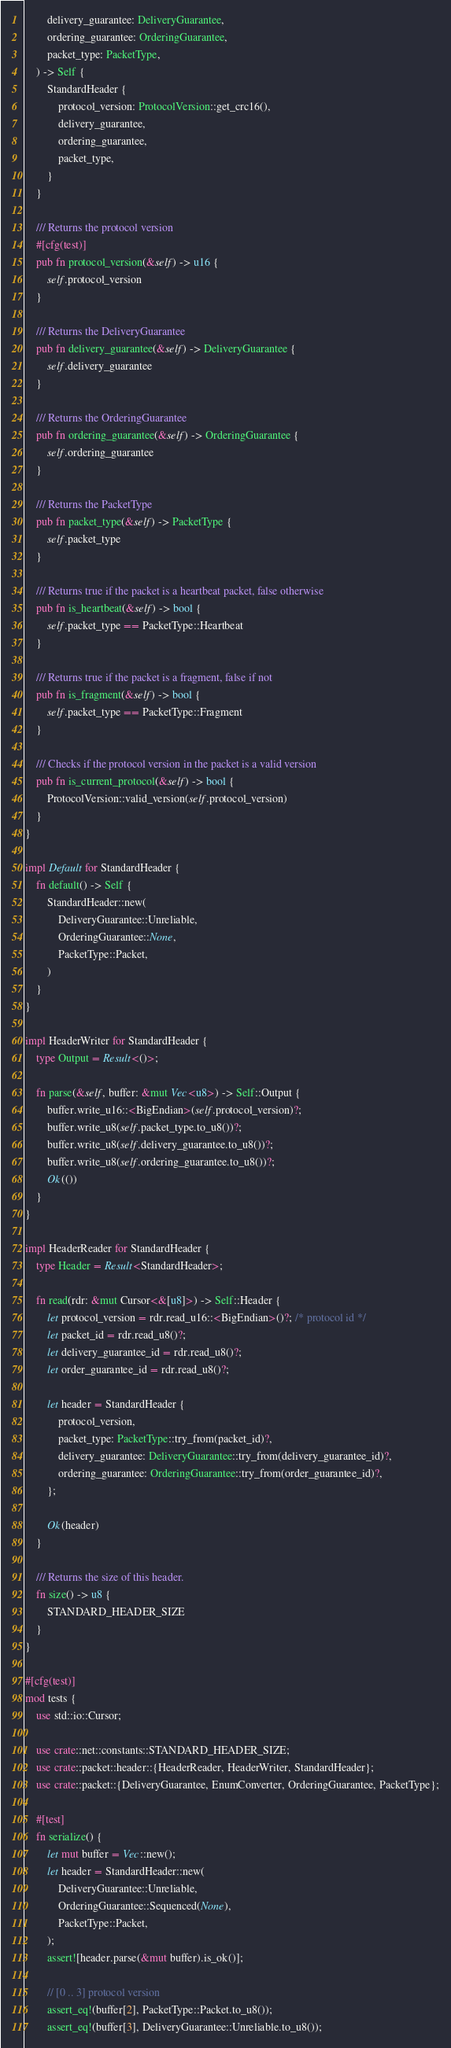Convert code to text. <code><loc_0><loc_0><loc_500><loc_500><_Rust_>        delivery_guarantee: DeliveryGuarantee,
        ordering_guarantee: OrderingGuarantee,
        packet_type: PacketType,
    ) -> Self {
        StandardHeader {
            protocol_version: ProtocolVersion::get_crc16(),
            delivery_guarantee,
            ordering_guarantee,
            packet_type,
        }
    }

    /// Returns the protocol version
    #[cfg(test)]
    pub fn protocol_version(&self) -> u16 {
        self.protocol_version
    }

    /// Returns the DeliveryGuarantee
    pub fn delivery_guarantee(&self) -> DeliveryGuarantee {
        self.delivery_guarantee
    }

    /// Returns the OrderingGuarantee
    pub fn ordering_guarantee(&self) -> OrderingGuarantee {
        self.ordering_guarantee
    }

    /// Returns the PacketType
    pub fn packet_type(&self) -> PacketType {
        self.packet_type
    }

    /// Returns true if the packet is a heartbeat packet, false otherwise
    pub fn is_heartbeat(&self) -> bool {
        self.packet_type == PacketType::Heartbeat
    }

    /// Returns true if the packet is a fragment, false if not
    pub fn is_fragment(&self) -> bool {
        self.packet_type == PacketType::Fragment
    }

    /// Checks if the protocol version in the packet is a valid version
    pub fn is_current_protocol(&self) -> bool {
        ProtocolVersion::valid_version(self.protocol_version)
    }
}

impl Default for StandardHeader {
    fn default() -> Self {
        StandardHeader::new(
            DeliveryGuarantee::Unreliable,
            OrderingGuarantee::None,
            PacketType::Packet,
        )
    }
}

impl HeaderWriter for StandardHeader {
    type Output = Result<()>;

    fn parse(&self, buffer: &mut Vec<u8>) -> Self::Output {
        buffer.write_u16::<BigEndian>(self.protocol_version)?;
        buffer.write_u8(self.packet_type.to_u8())?;
        buffer.write_u8(self.delivery_guarantee.to_u8())?;
        buffer.write_u8(self.ordering_guarantee.to_u8())?;
        Ok(())
    }
}

impl HeaderReader for StandardHeader {
    type Header = Result<StandardHeader>;

    fn read(rdr: &mut Cursor<&[u8]>) -> Self::Header {
        let protocol_version = rdr.read_u16::<BigEndian>()?; /* protocol id */
        let packet_id = rdr.read_u8()?;
        let delivery_guarantee_id = rdr.read_u8()?;
        let order_guarantee_id = rdr.read_u8()?;

        let header = StandardHeader {
            protocol_version,
            packet_type: PacketType::try_from(packet_id)?,
            delivery_guarantee: DeliveryGuarantee::try_from(delivery_guarantee_id)?,
            ordering_guarantee: OrderingGuarantee::try_from(order_guarantee_id)?,
        };

        Ok(header)
    }

    /// Returns the size of this header.
    fn size() -> u8 {
        STANDARD_HEADER_SIZE
    }
}

#[cfg(test)]
mod tests {
    use std::io::Cursor;

    use crate::net::constants::STANDARD_HEADER_SIZE;
    use crate::packet::header::{HeaderReader, HeaderWriter, StandardHeader};
    use crate::packet::{DeliveryGuarantee, EnumConverter, OrderingGuarantee, PacketType};

    #[test]
    fn serialize() {
        let mut buffer = Vec::new();
        let header = StandardHeader::new(
            DeliveryGuarantee::Unreliable,
            OrderingGuarantee::Sequenced(None),
            PacketType::Packet,
        );
        assert![header.parse(&mut buffer).is_ok()];

        // [0 .. 3] protocol version
        assert_eq!(buffer[2], PacketType::Packet.to_u8());
        assert_eq!(buffer[3], DeliveryGuarantee::Unreliable.to_u8());</code> 